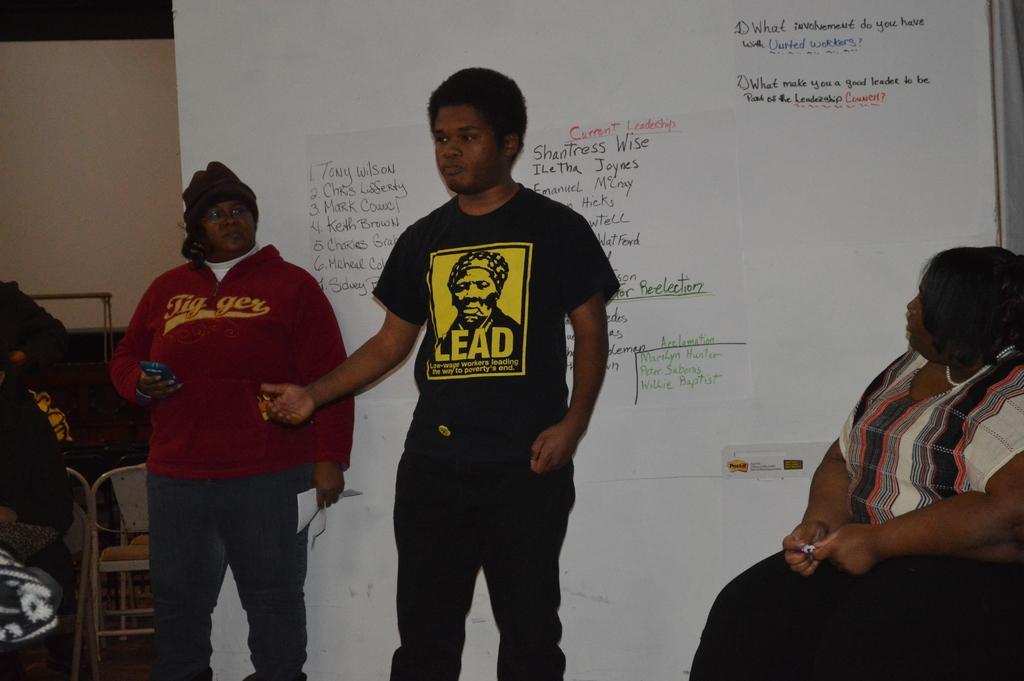Can you describe this image briefly? In the center of the image there are people standing. At the background of the image there is a white board. There is a wall. There is a chair to left side of the image. To the right side of the image there is a lady sitting. 